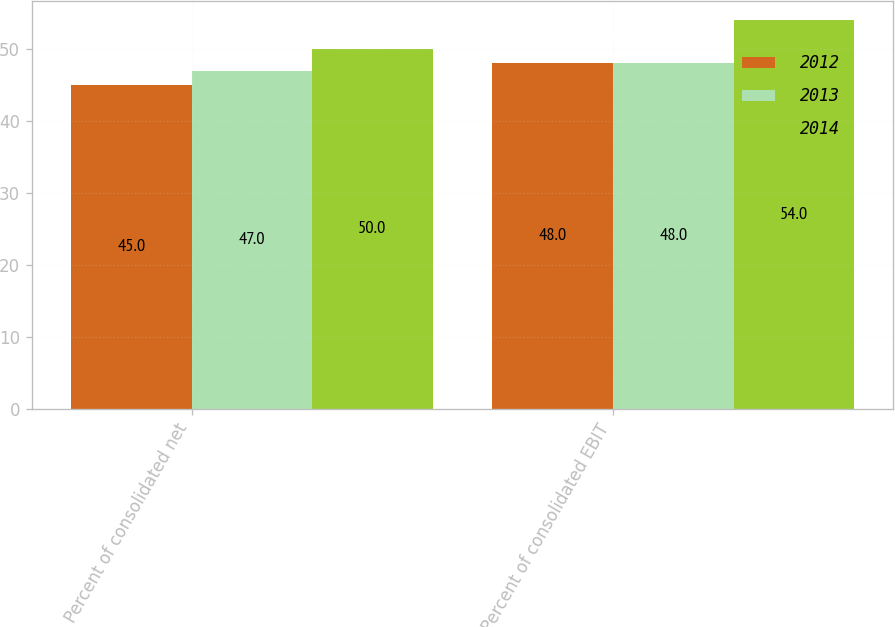Convert chart to OTSL. <chart><loc_0><loc_0><loc_500><loc_500><stacked_bar_chart><ecel><fcel>Percent of consolidated net<fcel>Percent of consolidated EBIT<nl><fcel>2012<fcel>45<fcel>48<nl><fcel>2013<fcel>47<fcel>48<nl><fcel>2014<fcel>50<fcel>54<nl></chart> 